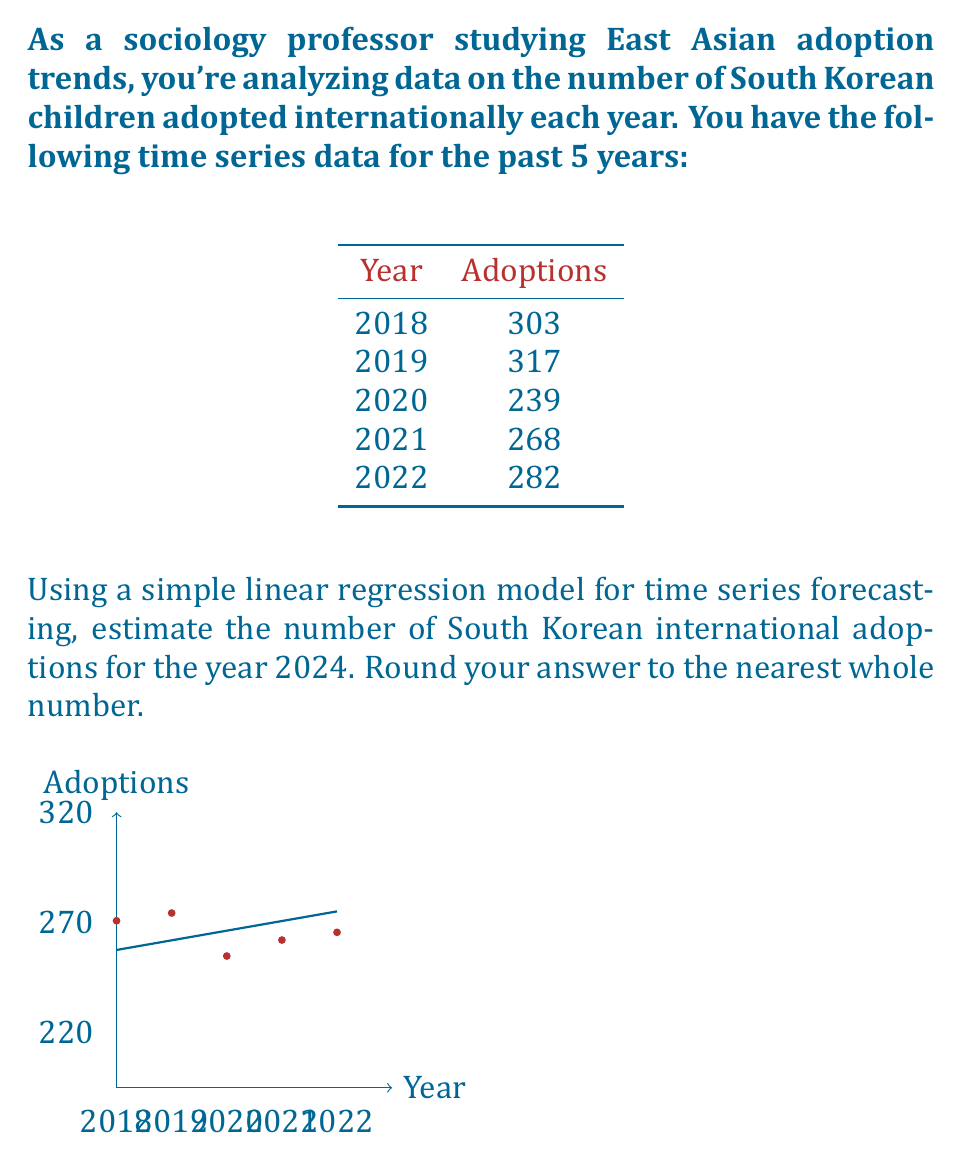What is the answer to this math problem? To estimate the number of adoptions for 2024 using simple linear regression, we'll follow these steps:

1. Assign numerical values to years:
   2018 → 0, 2019 → 1, 2020 → 2, 2021 → 3, 2022 → 4

2. Calculate the means of x (years) and y (adoptions):
   $\bar{x} = \frac{0 + 1 + 2 + 3 + 4}{5} = 2$
   $\bar{y} = \frac{303 + 317 + 239 + 268 + 282}{5} = 281.8$

3. Calculate the slope (b) of the regression line:
   $b = \frac{\sum(x_i - \bar{x})(y_i - \bar{y})}{\sum(x_i - \bar{x})^2}$

   $\sum(x_i - \bar{x})(y_i - \bar{y}) = (0-2)(303-281.8) + (1-2)(317-281.8) + (2-2)(239-281.8) + (3-2)(268-281.8) + (4-2)(282-281.8) = -42.4$

   $\sum(x_i - \bar{x})^2 = (-2)^2 + (-1)^2 + (0)^2 + (1)^2 + (2)^2 = 10$

   $b = \frac{-42.4}{10} = -4.24$

4. Calculate the y-intercept (a):
   $a = \bar{y} - b\bar{x} = 281.8 - (-4.24 \times 2) = 290.28$

5. The linear regression equation is:
   $y = -4.24x + 290.28$

6. To predict for 2024, we use x = 6 (as 2024 is 6 years after 2018):
   $y = -4.24(6) + 290.28 = 264.84$

7. Rounding to the nearest whole number:
   265
Answer: 265 